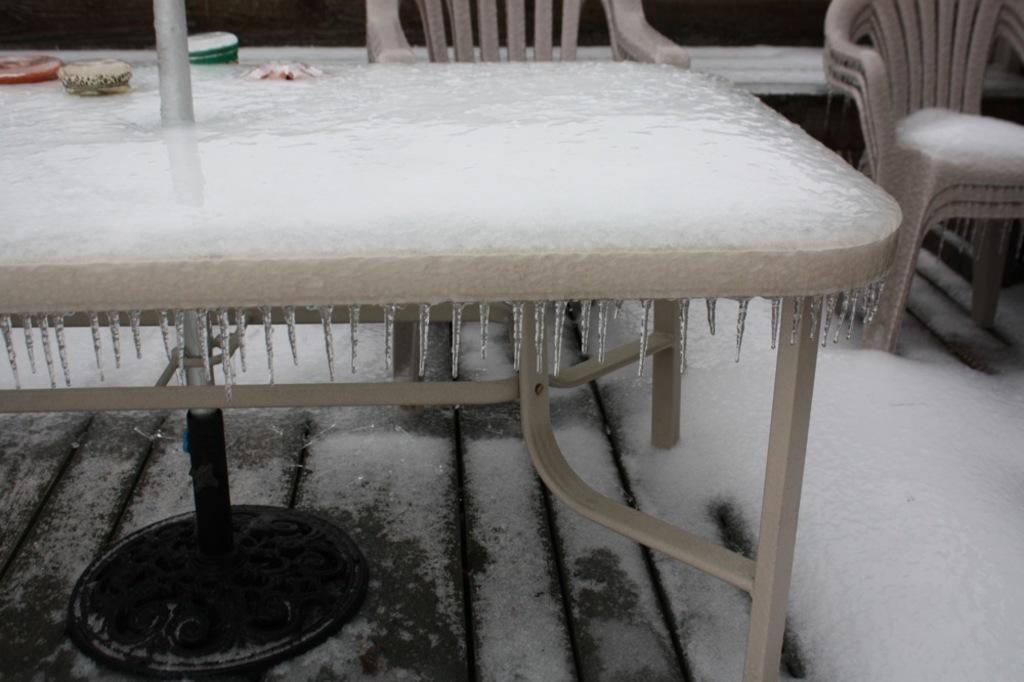Please provide a concise description of this image. In this image there is a table which is covered with the ice. In the background there are chairs which are also covered with the ice. At the bottom there is a floor on which there is ice. On the table there are some objects which are covered with the ice. 